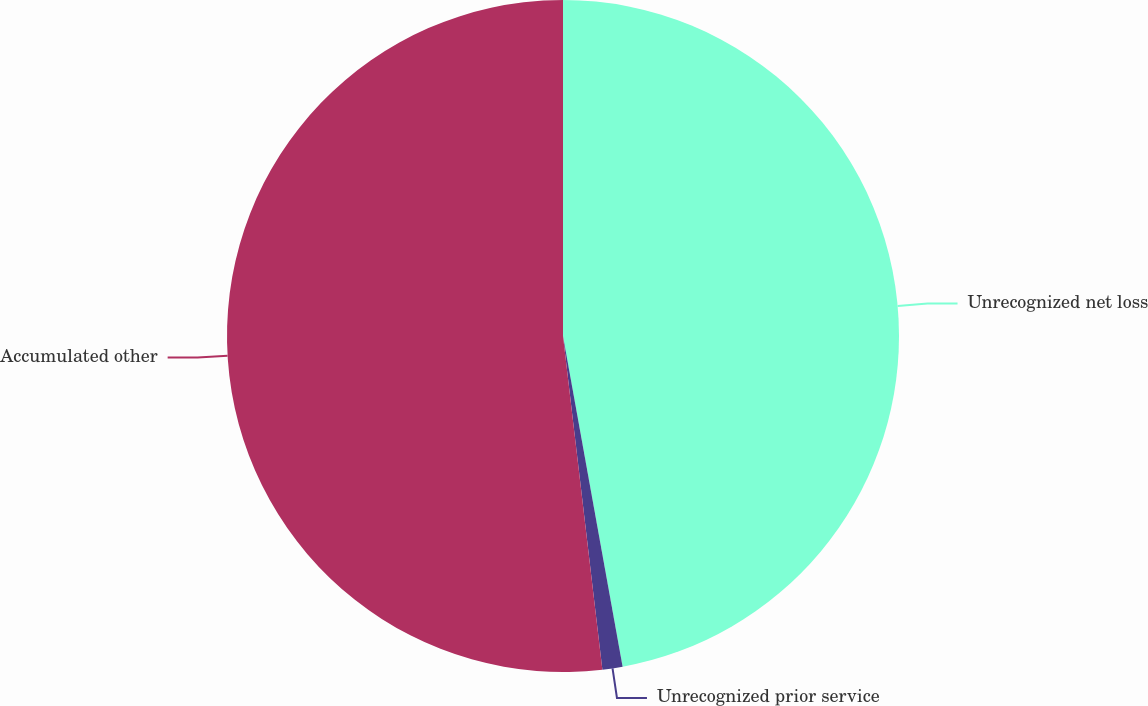<chart> <loc_0><loc_0><loc_500><loc_500><pie_chart><fcel>Unrecognized net loss<fcel>Unrecognized prior service<fcel>Accumulated other<nl><fcel>47.16%<fcel>0.97%<fcel>51.87%<nl></chart> 